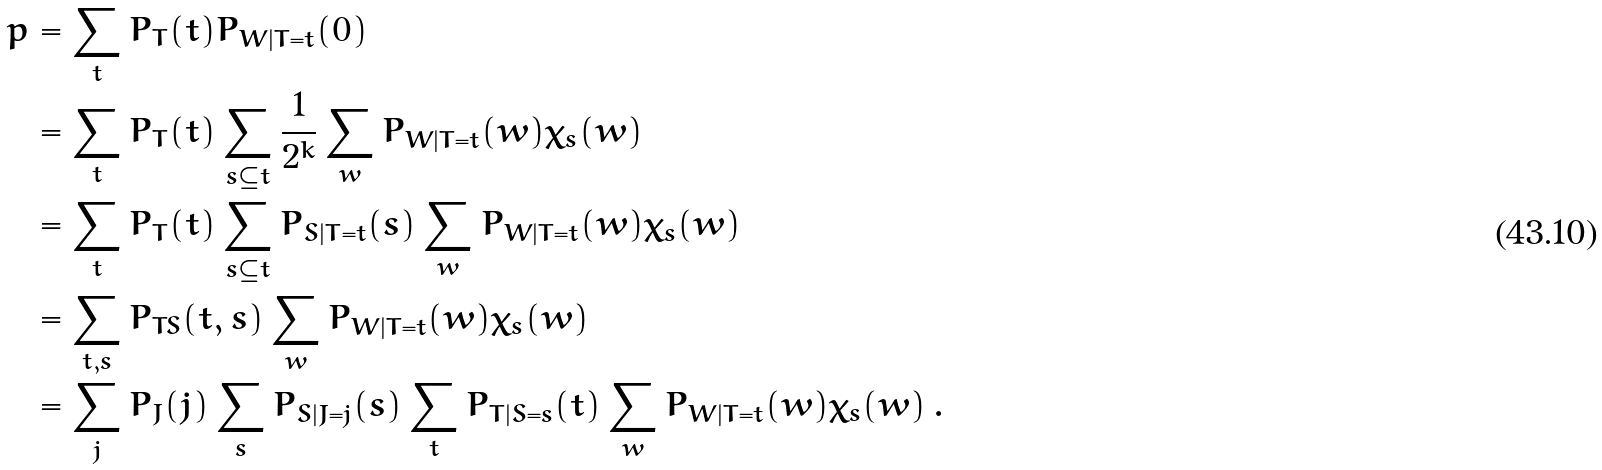Convert formula to latex. <formula><loc_0><loc_0><loc_500><loc_500>p & = \sum _ { t } P _ { T } ( t ) P _ { W | T = t } ( 0 ) \\ & = \sum _ { t } P _ { T } ( t ) \sum _ { s \subseteq t } \frac { 1 } { 2 ^ { k } } \sum _ { w } P _ { W | T = t } ( w ) \chi _ { s } ( w ) \\ & = \sum _ { t } P _ { T } ( t ) \sum _ { s \subseteq t } P _ { S | T = t } ( s ) \sum _ { w } P _ { W | T = t } ( w ) \chi _ { s } ( w ) \\ & = \sum _ { t , s } P _ { T S } ( t , s ) \sum _ { w } P _ { W | T = t } ( w ) \chi _ { s } ( w ) \\ & = \sum _ { j } P _ { J } ( j ) \sum _ { s } P _ { S | J = j } ( s ) \sum _ { t } P _ { T | S = s } ( t ) \sum _ { w } P _ { W | T = t } ( w ) \chi _ { s } ( w ) \, .</formula> 